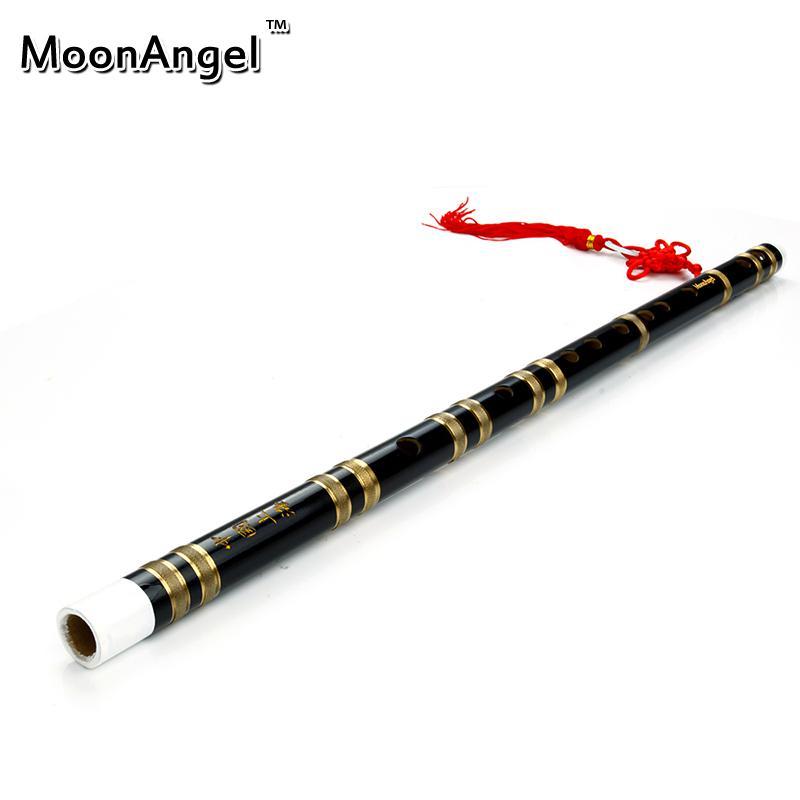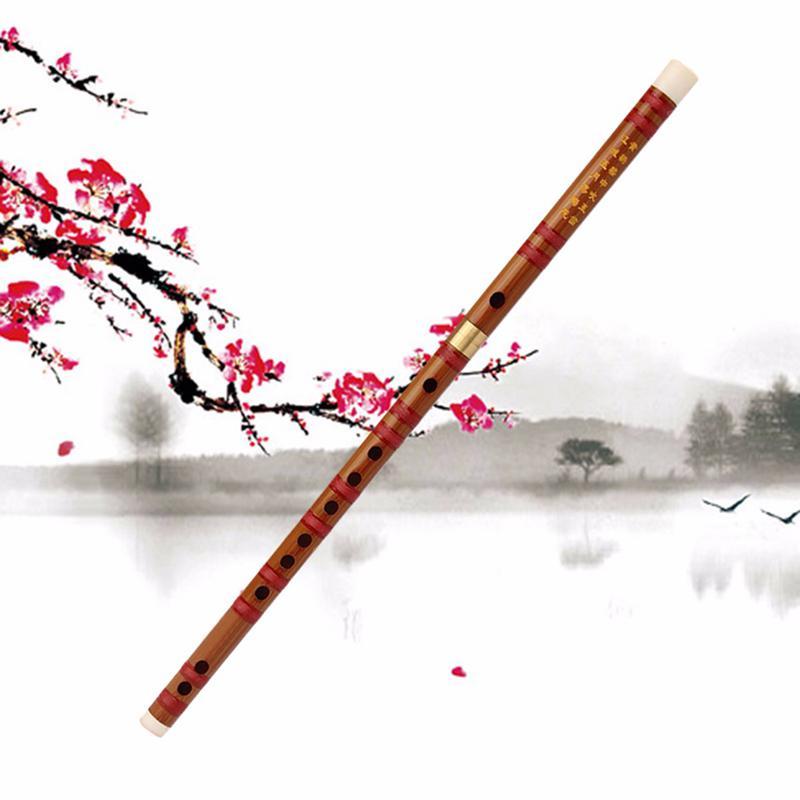The first image is the image on the left, the second image is the image on the right. Given the left and right images, does the statement "Each image contains one flute, which is displayed horizontally and has a red tassel at one end." hold true? Answer yes or no. No. The first image is the image on the left, the second image is the image on the right. Given the left and right images, does the statement "The left and right image contains the same number of flutes with red tassels." hold true? Answer yes or no. No. 